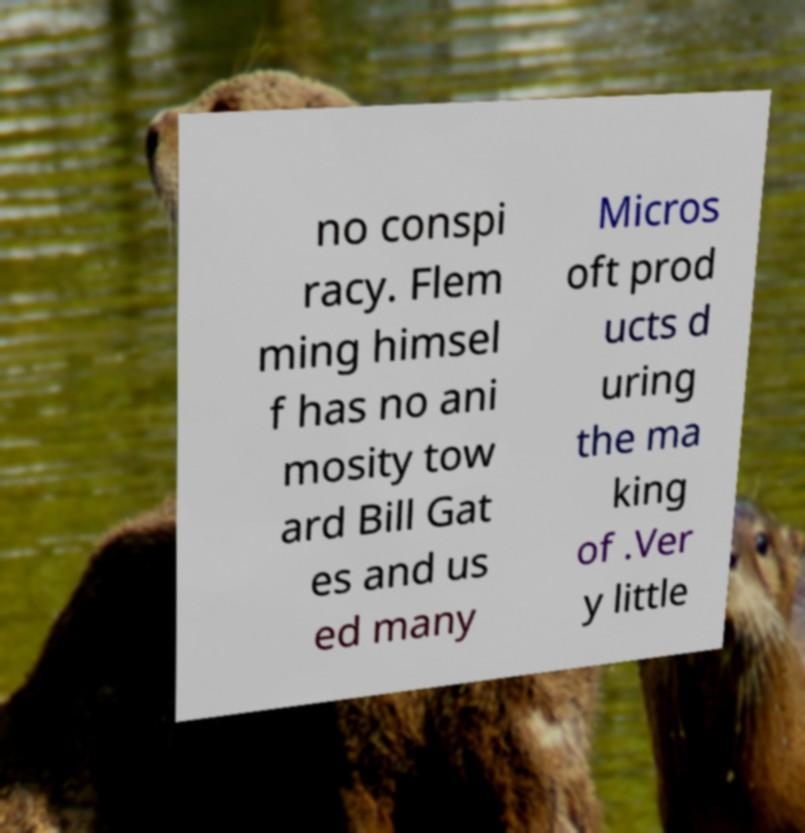There's text embedded in this image that I need extracted. Can you transcribe it verbatim? no conspi racy. Flem ming himsel f has no ani mosity tow ard Bill Gat es and us ed many Micros oft prod ucts d uring the ma king of .Ver y little 